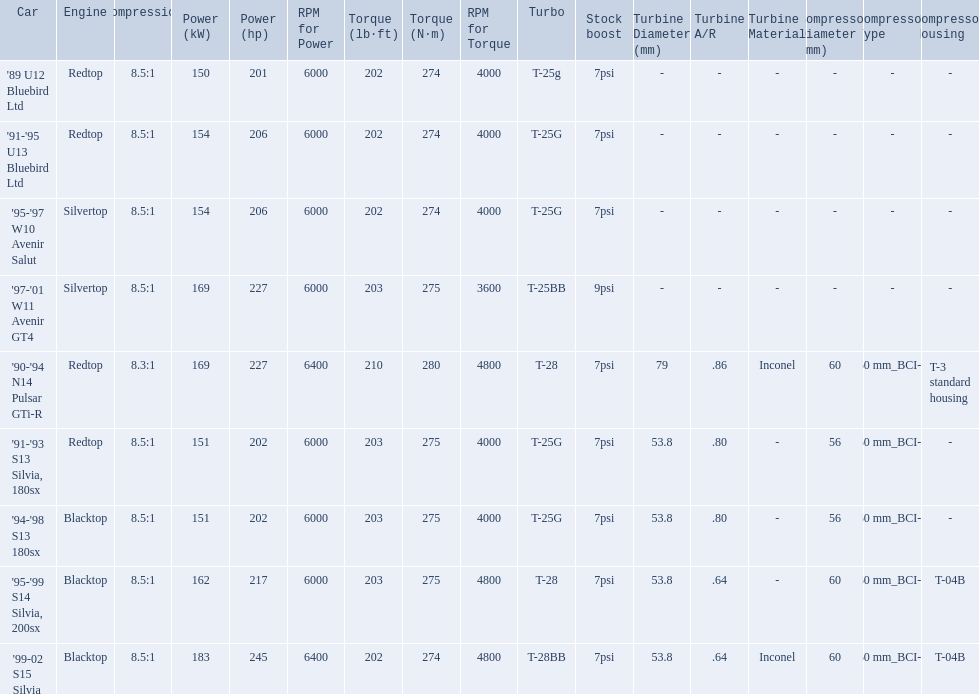Which engines were used after 1999? Silvertop, Blacktop. Can you give me this table as a dict? {'header': ['Car', 'Engine', 'Compression', 'Power (kW)', 'Power (hp)', 'RPM for Power', 'Torque (lb·ft)', 'Torque (N·m)', 'RPM for Torque', 'Turbo', 'Stock boost', 'Turbine Diameter (mm)', 'Turbine A/R', 'Turbine Material', 'Compressor Diameter (mm)', 'Compressor Type', 'Compressor Housing'], 'rows': [["'89 U12 Bluebird Ltd", 'Redtop', '8.5:1', '150', '201', '6000', '202', '274', '4000', 'T-25g', '7psi', '-', '-', '-', '-', '-', '-'], ["'91-'95 U13 Bluebird Ltd", 'Redtop', '8.5:1', '154', '206', '6000', '202', '274', '4000', 'T-25G', '7psi', '-', '-', '-', '-', '-', '-'], ["'95-'97 W10 Avenir Salut", 'Silvertop', '8.5:1', '154', '206', '6000', '202', '274', '4000', 'T-25G', '7psi', '-', '-', '-', '-', '-', '-'], ["'97-'01 W11 Avenir GT4", 'Silvertop', '8.5:1', '169', '227', '6000', '203', '275', '3600', 'T-25BB', '9psi', '-', '-', '-', '-', '-', '-'], ["'90-'94 N14 Pulsar GTi-R", 'Redtop', '8.3:1', '169', '227', '6400', '210', '280', '4800', 'T-28', '7psi', '79', '.86', 'Inconel', '60', '60\xa0mm_BCI-1', 'T-3 standard housing'], ["'91-'93 S13 Silvia, 180sx", 'Redtop', '8.5:1', '151', '202', '6000', '203', '275', '4000', 'T-25G', '7psi', '53.8', '.80', '-', '56', '60\xa0mm_BCI-1', '-'], ["'94-'98 S13 180sx", 'Blacktop', '8.5:1', '151', '202', '6000', '203', '275', '4000', 'T-25G', '7psi', '53.8', '.80', '-', '56', '60\xa0mm_BCI-1', '-'], ["'95-'99 S14 Silvia, 200sx", 'Blacktop', '8.5:1', '162', '217', '6000', '203', '275', '4800', 'T-28', '7psi', '53.8', '.64', '-', '60', '60\xa0mm_BCI-1', 'T-04B'], ["'99-02 S15 Silvia", 'Blacktop', '8.5:1', '183', '245', '6400', '202', '274', '4800', 'T-28BB', '7psi', '53.8', '.64', 'Inconel', '60', '60\xa0mm_BCI-1', 'T-04B']]} 